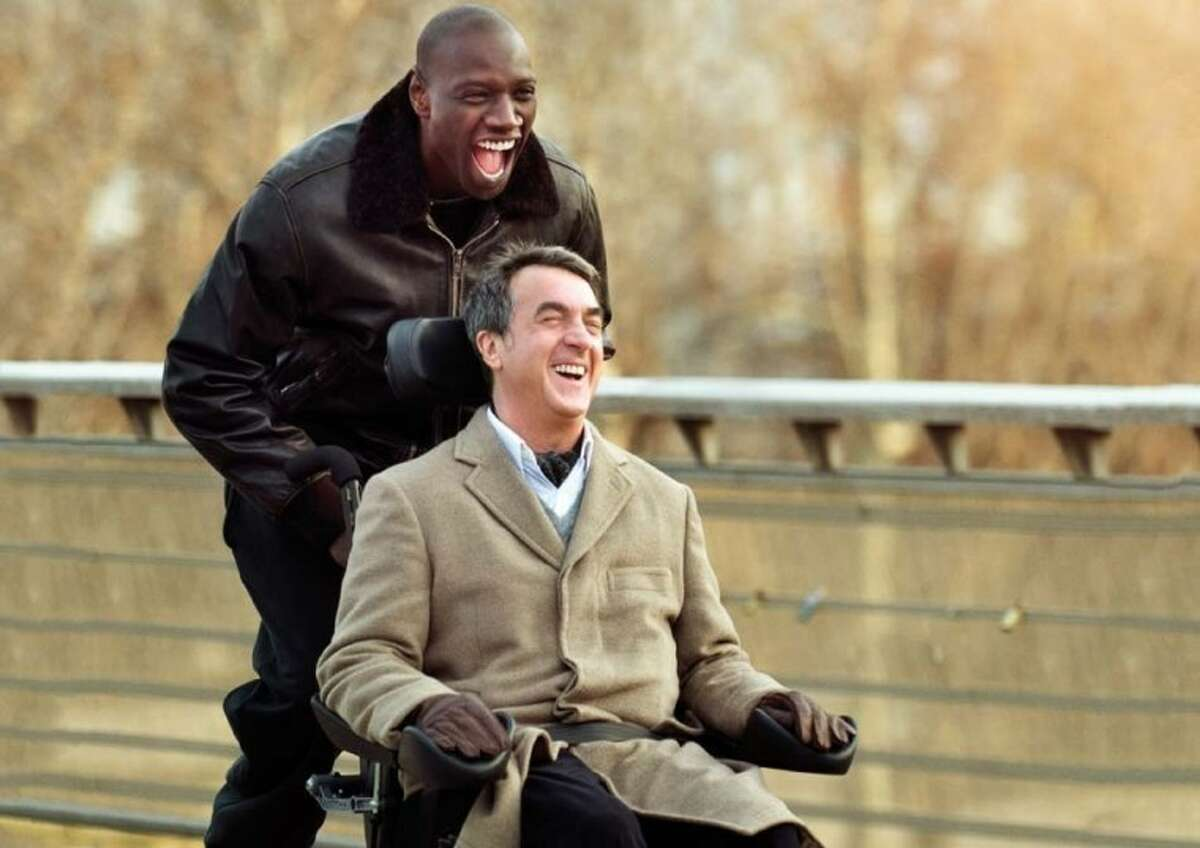Can you describe the main features of this image for me?
 In this image, we see a joyful moment from the movie "The Intouchables" featuring actors François Cluzet and Omar Sy. François Cluzet, portraying a character who uses a wheelchair, is at the forefront of the image. He's clad in a beige coat and his face is lit up with laughter. Omar Sy stands just behind him, donned in a black leather jacket, sharing in the mirth with his own wide smile. They are located on a bridge, surrounded by the serene backdrop of trees. 